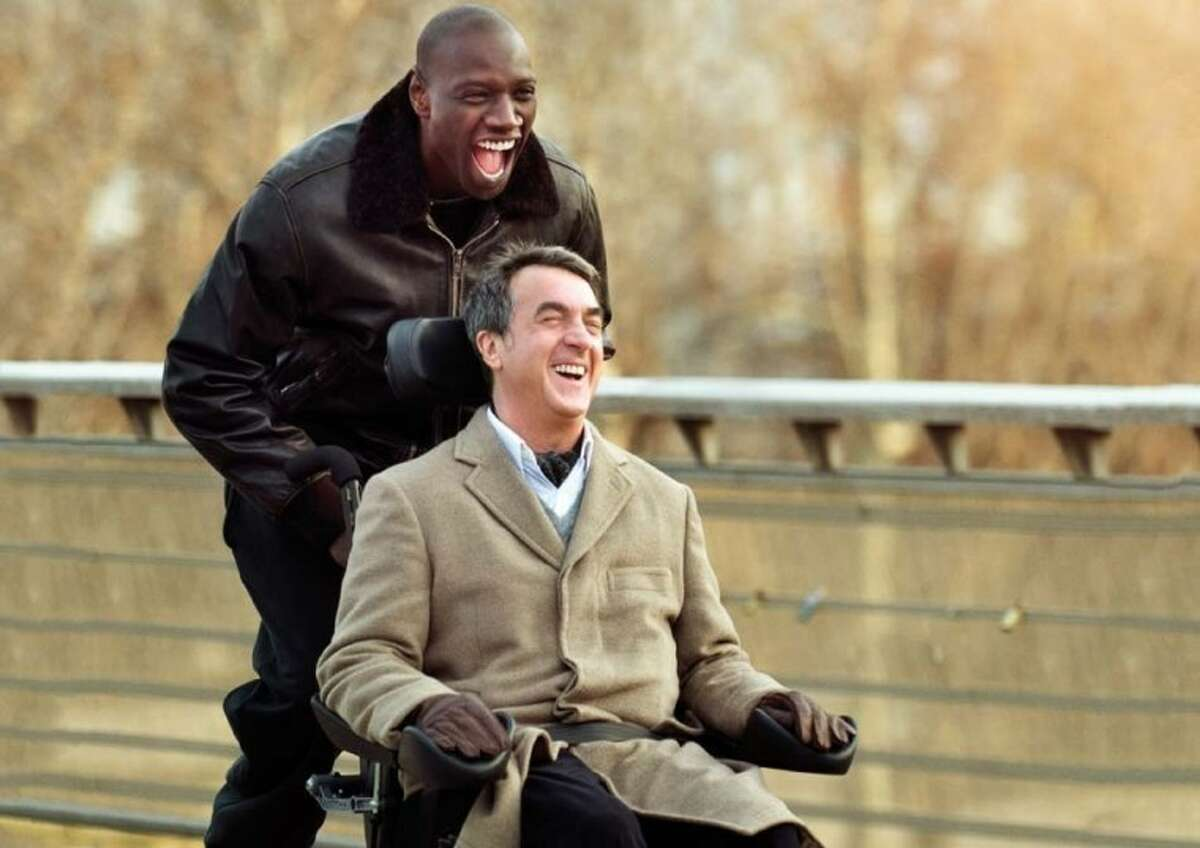Can you describe the main features of this image for me?
 In this image, we see a joyful moment from the movie "The Intouchables" featuring actors François Cluzet and Omar Sy. François Cluzet, portraying a character who uses a wheelchair, is at the forefront of the image. He's clad in a beige coat and his face is lit up with laughter. Omar Sy stands just behind him, donned in a black leather jacket, sharing in the mirth with his own wide smile. They are located on a bridge, surrounded by the serene backdrop of trees. 